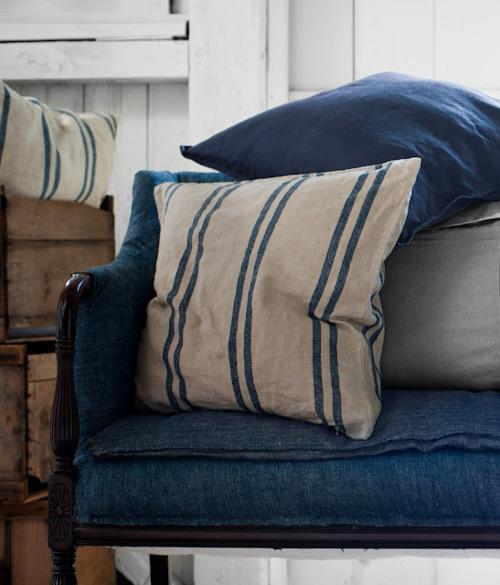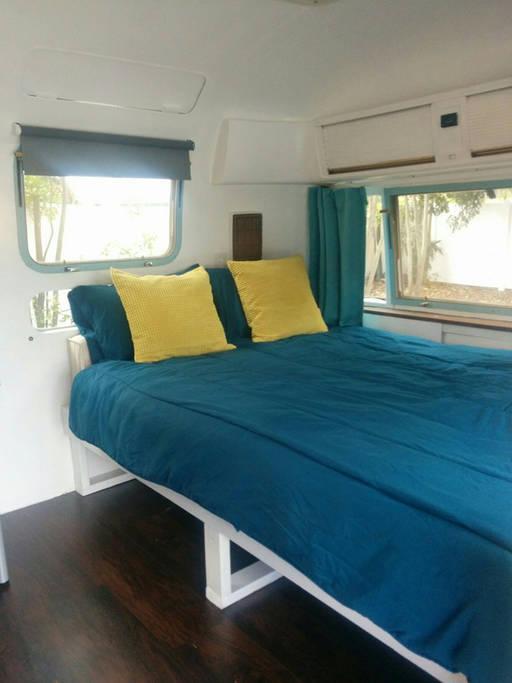The first image is the image on the left, the second image is the image on the right. Assess this claim about the two images: "An image shows a bed with a blue bedding component and two square non-white pillows facing forward.". Correct or not? Answer yes or no. Yes. The first image is the image on the left, the second image is the image on the right. Assess this claim about the two images: "The image to the left is clearly a bed.". Correct or not? Answer yes or no. No. 